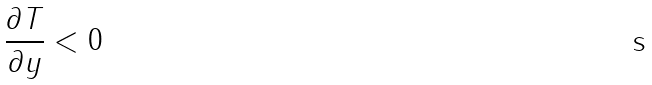Convert formula to latex. <formula><loc_0><loc_0><loc_500><loc_500>\frac { \partial T } { \partial y } < 0</formula> 